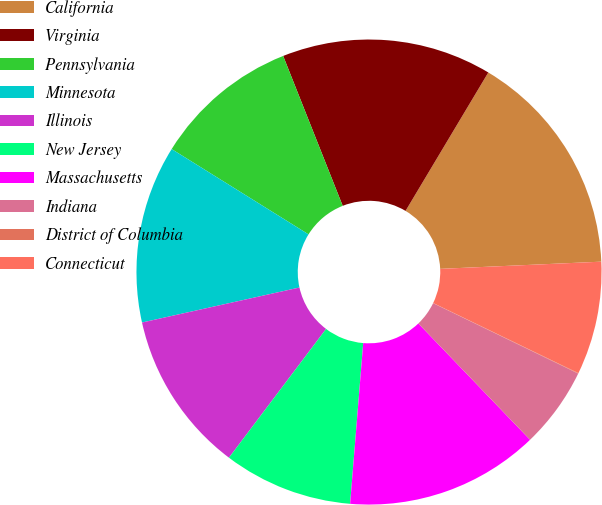<chart> <loc_0><loc_0><loc_500><loc_500><pie_chart><fcel>California<fcel>Virginia<fcel>Pennsylvania<fcel>Minnesota<fcel>Illinois<fcel>New Jersey<fcel>Massachusetts<fcel>Indiana<fcel>District of Columbia<fcel>Connecticut<nl><fcel>15.71%<fcel>14.59%<fcel>10.11%<fcel>12.35%<fcel>11.23%<fcel>8.99%<fcel>13.47%<fcel>5.63%<fcel>0.03%<fcel>7.87%<nl></chart> 